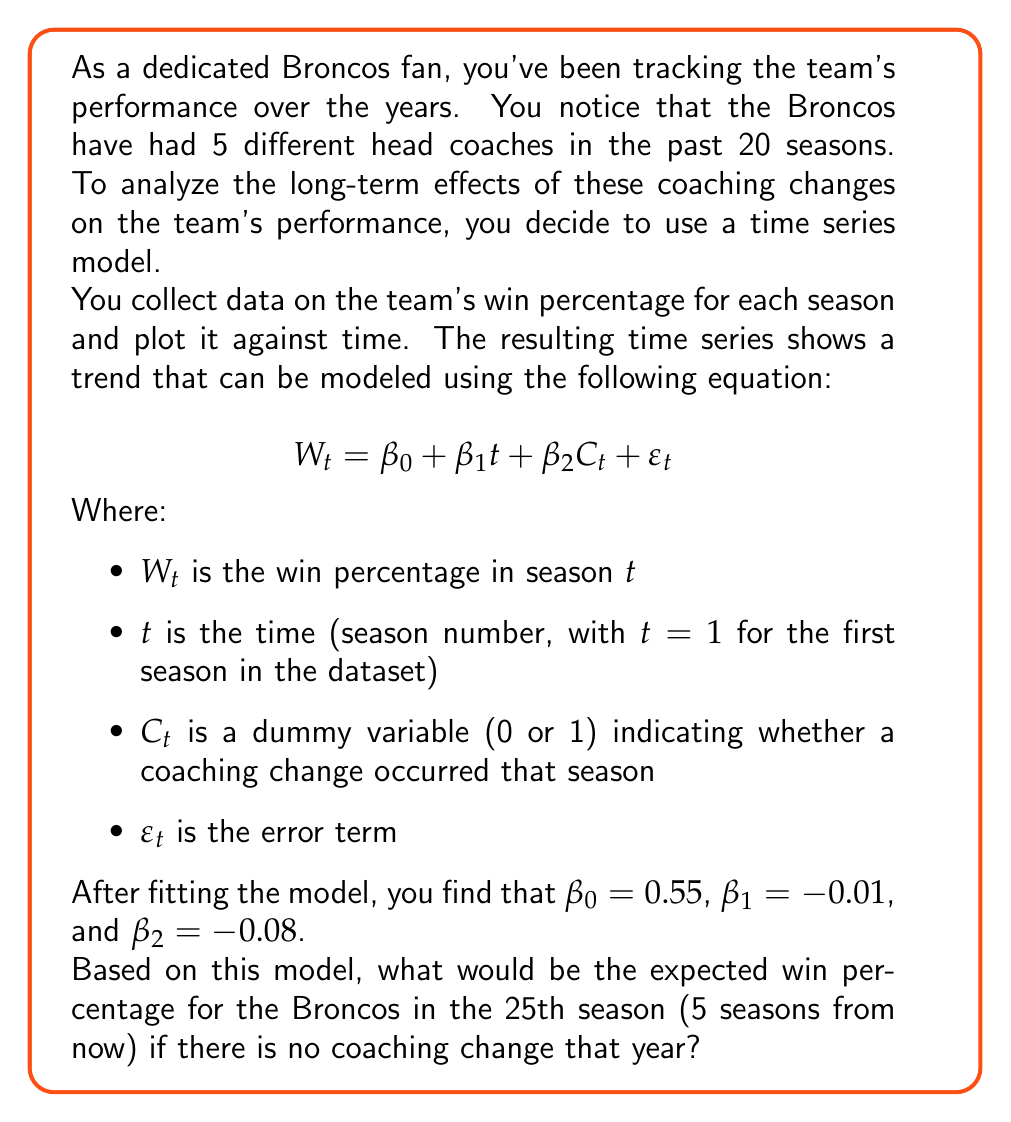Solve this math problem. Let's approach this step-by-step:

1) We are given the time series model:
   $$W_t = \beta_0 + \beta_1t + \beta_2C_t + \varepsilon_t$$

2) We know the values of the coefficients:
   $\beta_0 = 0.55$ (intercept)
   $\beta_1 = -0.01$ (trend coefficient)
   $\beta_2 = -0.08$ (coaching change coefficient)

3) We're asked about the 25th season, so t = 25

4) We're told there's no coaching change, so $C_t = 0$

5) We're looking for the expected value, so we ignore the error term $\varepsilon_t$

6) Let's plug these values into our equation:

   $$E(W_{25}) = \beta_0 + \beta_1(25) + \beta_2(0)$$

7) Substituting the known values:

   $$E(W_{25}) = 0.55 + (-0.01)(25) + (-0.08)(0)$$

8) Simplify:
   $$E(W_{25}) = 0.55 - 0.25 + 0 = 0.30$$

Therefore, the expected win percentage for the Broncos in the 25th season, assuming no coaching change, would be 0.30 or 30%.
Answer: 0.30 or 30% 